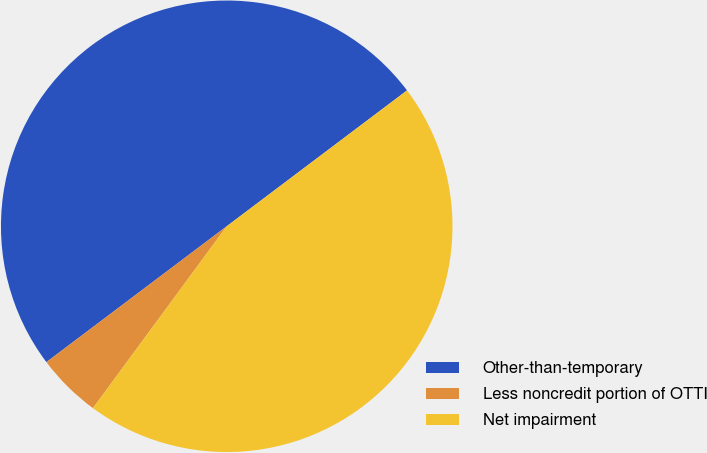<chart> <loc_0><loc_0><loc_500><loc_500><pie_chart><fcel>Other-than-temporary<fcel>Less noncredit portion of OTTI<fcel>Net impairment<nl><fcel>50.0%<fcel>4.63%<fcel>45.37%<nl></chart> 